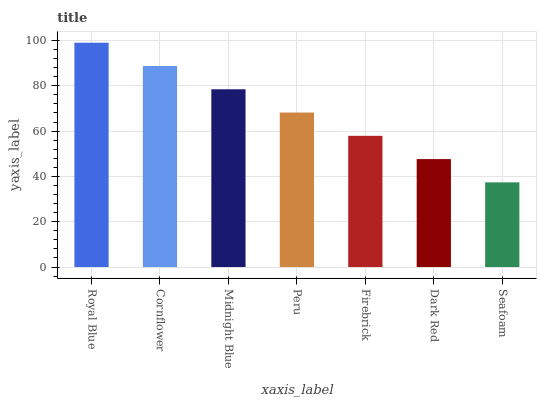Is Seafoam the minimum?
Answer yes or no. Yes. Is Royal Blue the maximum?
Answer yes or no. Yes. Is Cornflower the minimum?
Answer yes or no. No. Is Cornflower the maximum?
Answer yes or no. No. Is Royal Blue greater than Cornflower?
Answer yes or no. Yes. Is Cornflower less than Royal Blue?
Answer yes or no. Yes. Is Cornflower greater than Royal Blue?
Answer yes or no. No. Is Royal Blue less than Cornflower?
Answer yes or no. No. Is Peru the high median?
Answer yes or no. Yes. Is Peru the low median?
Answer yes or no. Yes. Is Cornflower the high median?
Answer yes or no. No. Is Royal Blue the low median?
Answer yes or no. No. 